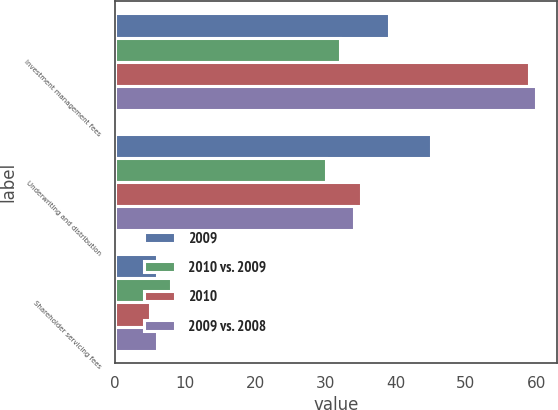<chart> <loc_0><loc_0><loc_500><loc_500><stacked_bar_chart><ecel><fcel>Investment management fees<fcel>Underwriting and distribution<fcel>Shareholder servicing fees<nl><fcel>2009<fcel>39<fcel>45<fcel>6<nl><fcel>2010 vs. 2009<fcel>32<fcel>30<fcel>8<nl><fcel>2010<fcel>59<fcel>35<fcel>5<nl><fcel>2009 vs. 2008<fcel>60<fcel>34<fcel>6<nl></chart> 